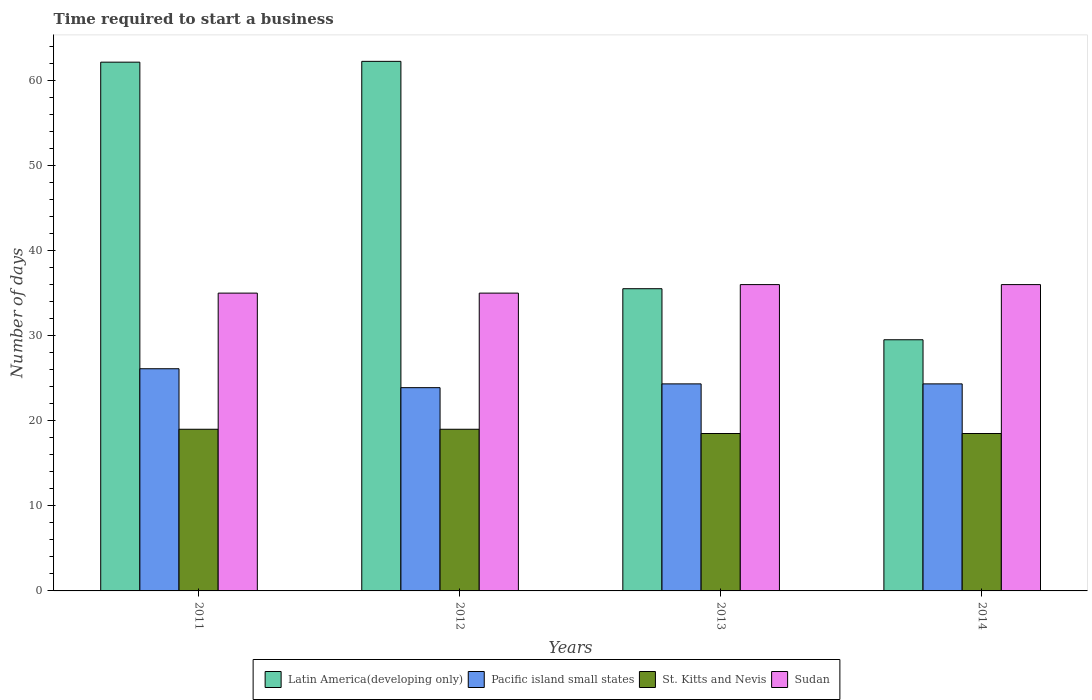Are the number of bars per tick equal to the number of legend labels?
Your response must be concise. Yes. Are the number of bars on each tick of the X-axis equal?
Your answer should be compact. Yes. How many bars are there on the 1st tick from the left?
Keep it short and to the point. 4. How many bars are there on the 1st tick from the right?
Offer a terse response. 4. What is the label of the 4th group of bars from the left?
Offer a very short reply. 2014. Across all years, what is the maximum number of days required to start a business in Sudan?
Provide a succinct answer. 36. Across all years, what is the minimum number of days required to start a business in St. Kitts and Nevis?
Your answer should be very brief. 18.5. In which year was the number of days required to start a business in St. Kitts and Nevis maximum?
Ensure brevity in your answer.  2011. What is the total number of days required to start a business in St. Kitts and Nevis in the graph?
Provide a short and direct response. 75. What is the difference between the number of days required to start a business in Pacific island small states in 2013 and that in 2014?
Provide a short and direct response. 0. What is the difference between the number of days required to start a business in St. Kitts and Nevis in 2011 and the number of days required to start a business in Sudan in 2012?
Ensure brevity in your answer.  -16. What is the average number of days required to start a business in St. Kitts and Nevis per year?
Offer a very short reply. 18.75. In the year 2014, what is the difference between the number of days required to start a business in Latin America(developing only) and number of days required to start a business in St. Kitts and Nevis?
Your answer should be compact. 11.02. In how many years, is the number of days required to start a business in Latin America(developing only) greater than 26 days?
Offer a terse response. 4. What is the ratio of the number of days required to start a business in Pacific island small states in 2011 to that in 2012?
Offer a very short reply. 1.09. What is the difference between the highest and the second highest number of days required to start a business in St. Kitts and Nevis?
Your answer should be compact. 0. What is the difference between the highest and the lowest number of days required to start a business in St. Kitts and Nevis?
Your response must be concise. 0.5. In how many years, is the number of days required to start a business in Latin America(developing only) greater than the average number of days required to start a business in Latin America(developing only) taken over all years?
Offer a terse response. 2. Is the sum of the number of days required to start a business in Pacific island small states in 2011 and 2012 greater than the maximum number of days required to start a business in Sudan across all years?
Your answer should be compact. Yes. What does the 4th bar from the left in 2011 represents?
Your answer should be compact. Sudan. What does the 1st bar from the right in 2011 represents?
Ensure brevity in your answer.  Sudan. Is it the case that in every year, the sum of the number of days required to start a business in Latin America(developing only) and number of days required to start a business in Pacific island small states is greater than the number of days required to start a business in St. Kitts and Nevis?
Give a very brief answer. Yes. How many bars are there?
Provide a succinct answer. 16. Are all the bars in the graph horizontal?
Offer a very short reply. No. What is the difference between two consecutive major ticks on the Y-axis?
Offer a very short reply. 10. How many legend labels are there?
Provide a succinct answer. 4. How are the legend labels stacked?
Make the answer very short. Horizontal. What is the title of the graph?
Provide a short and direct response. Time required to start a business. What is the label or title of the X-axis?
Offer a terse response. Years. What is the label or title of the Y-axis?
Make the answer very short. Number of days. What is the Number of days of Latin America(developing only) in 2011?
Ensure brevity in your answer.  62.14. What is the Number of days in Pacific island small states in 2011?
Provide a short and direct response. 26.11. What is the Number of days of Sudan in 2011?
Ensure brevity in your answer.  35. What is the Number of days of Latin America(developing only) in 2012?
Offer a very short reply. 62.24. What is the Number of days of Pacific island small states in 2012?
Offer a very short reply. 23.89. What is the Number of days in St. Kitts and Nevis in 2012?
Provide a succinct answer. 19. What is the Number of days in Latin America(developing only) in 2013?
Provide a short and direct response. 35.52. What is the Number of days in Pacific island small states in 2013?
Your answer should be very brief. 24.33. What is the Number of days in St. Kitts and Nevis in 2013?
Your response must be concise. 18.5. What is the Number of days in Sudan in 2013?
Offer a terse response. 36. What is the Number of days in Latin America(developing only) in 2014?
Make the answer very short. 29.52. What is the Number of days of Pacific island small states in 2014?
Provide a short and direct response. 24.33. What is the Number of days in St. Kitts and Nevis in 2014?
Provide a short and direct response. 18.5. What is the Number of days of Sudan in 2014?
Your answer should be compact. 36. Across all years, what is the maximum Number of days in Latin America(developing only)?
Offer a terse response. 62.24. Across all years, what is the maximum Number of days in Pacific island small states?
Provide a short and direct response. 26.11. Across all years, what is the maximum Number of days in St. Kitts and Nevis?
Give a very brief answer. 19. Across all years, what is the maximum Number of days of Sudan?
Ensure brevity in your answer.  36. Across all years, what is the minimum Number of days of Latin America(developing only)?
Offer a terse response. 29.52. Across all years, what is the minimum Number of days of Pacific island small states?
Your response must be concise. 23.89. What is the total Number of days of Latin America(developing only) in the graph?
Offer a terse response. 189.42. What is the total Number of days in Pacific island small states in the graph?
Provide a short and direct response. 98.67. What is the total Number of days of St. Kitts and Nevis in the graph?
Provide a short and direct response. 75. What is the total Number of days of Sudan in the graph?
Offer a very short reply. 142. What is the difference between the Number of days of Latin America(developing only) in 2011 and that in 2012?
Make the answer very short. -0.1. What is the difference between the Number of days in Pacific island small states in 2011 and that in 2012?
Provide a short and direct response. 2.22. What is the difference between the Number of days in Latin America(developing only) in 2011 and that in 2013?
Your answer should be very brief. 26.63. What is the difference between the Number of days in Pacific island small states in 2011 and that in 2013?
Offer a terse response. 1.78. What is the difference between the Number of days of St. Kitts and Nevis in 2011 and that in 2013?
Your answer should be very brief. 0.5. What is the difference between the Number of days in Latin America(developing only) in 2011 and that in 2014?
Your answer should be compact. 32.63. What is the difference between the Number of days of Pacific island small states in 2011 and that in 2014?
Offer a terse response. 1.78. What is the difference between the Number of days in St. Kitts and Nevis in 2011 and that in 2014?
Ensure brevity in your answer.  0.5. What is the difference between the Number of days of Latin America(developing only) in 2012 and that in 2013?
Give a very brief answer. 26.72. What is the difference between the Number of days of Pacific island small states in 2012 and that in 2013?
Offer a terse response. -0.44. What is the difference between the Number of days of Sudan in 2012 and that in 2013?
Provide a succinct answer. -1. What is the difference between the Number of days of Latin America(developing only) in 2012 and that in 2014?
Keep it short and to the point. 32.72. What is the difference between the Number of days in Pacific island small states in 2012 and that in 2014?
Your answer should be compact. -0.44. What is the difference between the Number of days in Sudan in 2012 and that in 2014?
Your answer should be very brief. -1. What is the difference between the Number of days of Latin America(developing only) in 2013 and that in 2014?
Offer a terse response. 6. What is the difference between the Number of days in St. Kitts and Nevis in 2013 and that in 2014?
Make the answer very short. 0. What is the difference between the Number of days in Latin America(developing only) in 2011 and the Number of days in Pacific island small states in 2012?
Your response must be concise. 38.25. What is the difference between the Number of days in Latin America(developing only) in 2011 and the Number of days in St. Kitts and Nevis in 2012?
Keep it short and to the point. 43.14. What is the difference between the Number of days of Latin America(developing only) in 2011 and the Number of days of Sudan in 2012?
Provide a short and direct response. 27.14. What is the difference between the Number of days of Pacific island small states in 2011 and the Number of days of St. Kitts and Nevis in 2012?
Offer a very short reply. 7.11. What is the difference between the Number of days in Pacific island small states in 2011 and the Number of days in Sudan in 2012?
Ensure brevity in your answer.  -8.89. What is the difference between the Number of days of St. Kitts and Nevis in 2011 and the Number of days of Sudan in 2012?
Give a very brief answer. -16. What is the difference between the Number of days of Latin America(developing only) in 2011 and the Number of days of Pacific island small states in 2013?
Provide a succinct answer. 37.81. What is the difference between the Number of days in Latin America(developing only) in 2011 and the Number of days in St. Kitts and Nevis in 2013?
Ensure brevity in your answer.  43.64. What is the difference between the Number of days in Latin America(developing only) in 2011 and the Number of days in Sudan in 2013?
Your answer should be very brief. 26.14. What is the difference between the Number of days of Pacific island small states in 2011 and the Number of days of St. Kitts and Nevis in 2013?
Your response must be concise. 7.61. What is the difference between the Number of days in Pacific island small states in 2011 and the Number of days in Sudan in 2013?
Ensure brevity in your answer.  -9.89. What is the difference between the Number of days of Latin America(developing only) in 2011 and the Number of days of Pacific island small states in 2014?
Make the answer very short. 37.81. What is the difference between the Number of days of Latin America(developing only) in 2011 and the Number of days of St. Kitts and Nevis in 2014?
Your answer should be compact. 43.64. What is the difference between the Number of days of Latin America(developing only) in 2011 and the Number of days of Sudan in 2014?
Offer a very short reply. 26.14. What is the difference between the Number of days of Pacific island small states in 2011 and the Number of days of St. Kitts and Nevis in 2014?
Your answer should be compact. 7.61. What is the difference between the Number of days of Pacific island small states in 2011 and the Number of days of Sudan in 2014?
Your answer should be compact. -9.89. What is the difference between the Number of days in St. Kitts and Nevis in 2011 and the Number of days in Sudan in 2014?
Provide a short and direct response. -17. What is the difference between the Number of days of Latin America(developing only) in 2012 and the Number of days of Pacific island small states in 2013?
Give a very brief answer. 37.9. What is the difference between the Number of days in Latin America(developing only) in 2012 and the Number of days in St. Kitts and Nevis in 2013?
Keep it short and to the point. 43.74. What is the difference between the Number of days in Latin America(developing only) in 2012 and the Number of days in Sudan in 2013?
Make the answer very short. 26.24. What is the difference between the Number of days of Pacific island small states in 2012 and the Number of days of St. Kitts and Nevis in 2013?
Provide a succinct answer. 5.39. What is the difference between the Number of days in Pacific island small states in 2012 and the Number of days in Sudan in 2013?
Your response must be concise. -12.11. What is the difference between the Number of days in Latin America(developing only) in 2012 and the Number of days in Pacific island small states in 2014?
Offer a very short reply. 37.9. What is the difference between the Number of days of Latin America(developing only) in 2012 and the Number of days of St. Kitts and Nevis in 2014?
Your response must be concise. 43.74. What is the difference between the Number of days of Latin America(developing only) in 2012 and the Number of days of Sudan in 2014?
Offer a very short reply. 26.24. What is the difference between the Number of days of Pacific island small states in 2012 and the Number of days of St. Kitts and Nevis in 2014?
Your response must be concise. 5.39. What is the difference between the Number of days of Pacific island small states in 2012 and the Number of days of Sudan in 2014?
Provide a succinct answer. -12.11. What is the difference between the Number of days of Latin America(developing only) in 2013 and the Number of days of Pacific island small states in 2014?
Offer a terse response. 11.18. What is the difference between the Number of days in Latin America(developing only) in 2013 and the Number of days in St. Kitts and Nevis in 2014?
Your answer should be compact. 17.02. What is the difference between the Number of days of Latin America(developing only) in 2013 and the Number of days of Sudan in 2014?
Your response must be concise. -0.48. What is the difference between the Number of days in Pacific island small states in 2013 and the Number of days in St. Kitts and Nevis in 2014?
Your answer should be compact. 5.83. What is the difference between the Number of days in Pacific island small states in 2013 and the Number of days in Sudan in 2014?
Ensure brevity in your answer.  -11.67. What is the difference between the Number of days of St. Kitts and Nevis in 2013 and the Number of days of Sudan in 2014?
Give a very brief answer. -17.5. What is the average Number of days of Latin America(developing only) per year?
Ensure brevity in your answer.  47.35. What is the average Number of days of Pacific island small states per year?
Offer a very short reply. 24.67. What is the average Number of days in St. Kitts and Nevis per year?
Make the answer very short. 18.75. What is the average Number of days in Sudan per year?
Offer a very short reply. 35.5. In the year 2011, what is the difference between the Number of days in Latin America(developing only) and Number of days in Pacific island small states?
Give a very brief answer. 36.03. In the year 2011, what is the difference between the Number of days of Latin America(developing only) and Number of days of St. Kitts and Nevis?
Ensure brevity in your answer.  43.14. In the year 2011, what is the difference between the Number of days of Latin America(developing only) and Number of days of Sudan?
Keep it short and to the point. 27.14. In the year 2011, what is the difference between the Number of days in Pacific island small states and Number of days in St. Kitts and Nevis?
Give a very brief answer. 7.11. In the year 2011, what is the difference between the Number of days in Pacific island small states and Number of days in Sudan?
Your answer should be compact. -8.89. In the year 2011, what is the difference between the Number of days in St. Kitts and Nevis and Number of days in Sudan?
Provide a succinct answer. -16. In the year 2012, what is the difference between the Number of days in Latin America(developing only) and Number of days in Pacific island small states?
Provide a succinct answer. 38.35. In the year 2012, what is the difference between the Number of days in Latin America(developing only) and Number of days in St. Kitts and Nevis?
Provide a short and direct response. 43.24. In the year 2012, what is the difference between the Number of days of Latin America(developing only) and Number of days of Sudan?
Provide a short and direct response. 27.24. In the year 2012, what is the difference between the Number of days in Pacific island small states and Number of days in St. Kitts and Nevis?
Give a very brief answer. 4.89. In the year 2012, what is the difference between the Number of days in Pacific island small states and Number of days in Sudan?
Your response must be concise. -11.11. In the year 2013, what is the difference between the Number of days of Latin America(developing only) and Number of days of Pacific island small states?
Keep it short and to the point. 11.18. In the year 2013, what is the difference between the Number of days in Latin America(developing only) and Number of days in St. Kitts and Nevis?
Your response must be concise. 17.02. In the year 2013, what is the difference between the Number of days in Latin America(developing only) and Number of days in Sudan?
Your answer should be compact. -0.48. In the year 2013, what is the difference between the Number of days of Pacific island small states and Number of days of St. Kitts and Nevis?
Your answer should be compact. 5.83. In the year 2013, what is the difference between the Number of days in Pacific island small states and Number of days in Sudan?
Keep it short and to the point. -11.67. In the year 2013, what is the difference between the Number of days in St. Kitts and Nevis and Number of days in Sudan?
Keep it short and to the point. -17.5. In the year 2014, what is the difference between the Number of days in Latin America(developing only) and Number of days in Pacific island small states?
Provide a short and direct response. 5.18. In the year 2014, what is the difference between the Number of days in Latin America(developing only) and Number of days in St. Kitts and Nevis?
Provide a short and direct response. 11.02. In the year 2014, what is the difference between the Number of days of Latin America(developing only) and Number of days of Sudan?
Give a very brief answer. -6.48. In the year 2014, what is the difference between the Number of days of Pacific island small states and Number of days of St. Kitts and Nevis?
Offer a very short reply. 5.83. In the year 2014, what is the difference between the Number of days in Pacific island small states and Number of days in Sudan?
Ensure brevity in your answer.  -11.67. In the year 2014, what is the difference between the Number of days in St. Kitts and Nevis and Number of days in Sudan?
Offer a terse response. -17.5. What is the ratio of the Number of days of Latin America(developing only) in 2011 to that in 2012?
Offer a very short reply. 1. What is the ratio of the Number of days in Pacific island small states in 2011 to that in 2012?
Give a very brief answer. 1.09. What is the ratio of the Number of days of Latin America(developing only) in 2011 to that in 2013?
Provide a short and direct response. 1.75. What is the ratio of the Number of days of Pacific island small states in 2011 to that in 2013?
Your response must be concise. 1.07. What is the ratio of the Number of days of St. Kitts and Nevis in 2011 to that in 2013?
Give a very brief answer. 1.03. What is the ratio of the Number of days in Sudan in 2011 to that in 2013?
Your answer should be compact. 0.97. What is the ratio of the Number of days of Latin America(developing only) in 2011 to that in 2014?
Offer a terse response. 2.11. What is the ratio of the Number of days in Pacific island small states in 2011 to that in 2014?
Ensure brevity in your answer.  1.07. What is the ratio of the Number of days of St. Kitts and Nevis in 2011 to that in 2014?
Make the answer very short. 1.03. What is the ratio of the Number of days in Sudan in 2011 to that in 2014?
Offer a terse response. 0.97. What is the ratio of the Number of days of Latin America(developing only) in 2012 to that in 2013?
Provide a short and direct response. 1.75. What is the ratio of the Number of days in Pacific island small states in 2012 to that in 2013?
Provide a succinct answer. 0.98. What is the ratio of the Number of days of Sudan in 2012 to that in 2013?
Offer a terse response. 0.97. What is the ratio of the Number of days in Latin America(developing only) in 2012 to that in 2014?
Keep it short and to the point. 2.11. What is the ratio of the Number of days in Pacific island small states in 2012 to that in 2014?
Your answer should be very brief. 0.98. What is the ratio of the Number of days in Sudan in 2012 to that in 2014?
Offer a terse response. 0.97. What is the ratio of the Number of days of Latin America(developing only) in 2013 to that in 2014?
Offer a terse response. 1.2. What is the ratio of the Number of days of Pacific island small states in 2013 to that in 2014?
Provide a succinct answer. 1. What is the difference between the highest and the second highest Number of days in Latin America(developing only)?
Offer a very short reply. 0.1. What is the difference between the highest and the second highest Number of days in Pacific island small states?
Give a very brief answer. 1.78. What is the difference between the highest and the second highest Number of days in St. Kitts and Nevis?
Your response must be concise. 0. What is the difference between the highest and the second highest Number of days in Sudan?
Keep it short and to the point. 0. What is the difference between the highest and the lowest Number of days in Latin America(developing only)?
Provide a succinct answer. 32.72. What is the difference between the highest and the lowest Number of days in Pacific island small states?
Provide a short and direct response. 2.22. What is the difference between the highest and the lowest Number of days in St. Kitts and Nevis?
Ensure brevity in your answer.  0.5. 